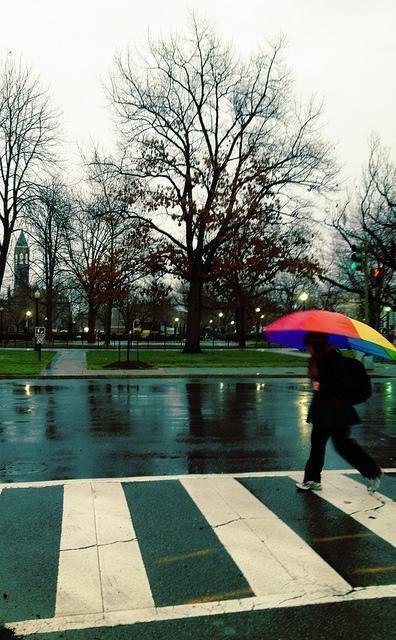What is the person with the umbrella walking on?
Select the accurate response from the four choices given to answer the question.
Options: Stairs, sidewalk, escalator, zebra stripes. Zebra stripes. What is the person walking on?
Indicate the correct response by choosing from the four available options to answer the question.
Options: Hot coals, street, dirt road, snow. Street. 